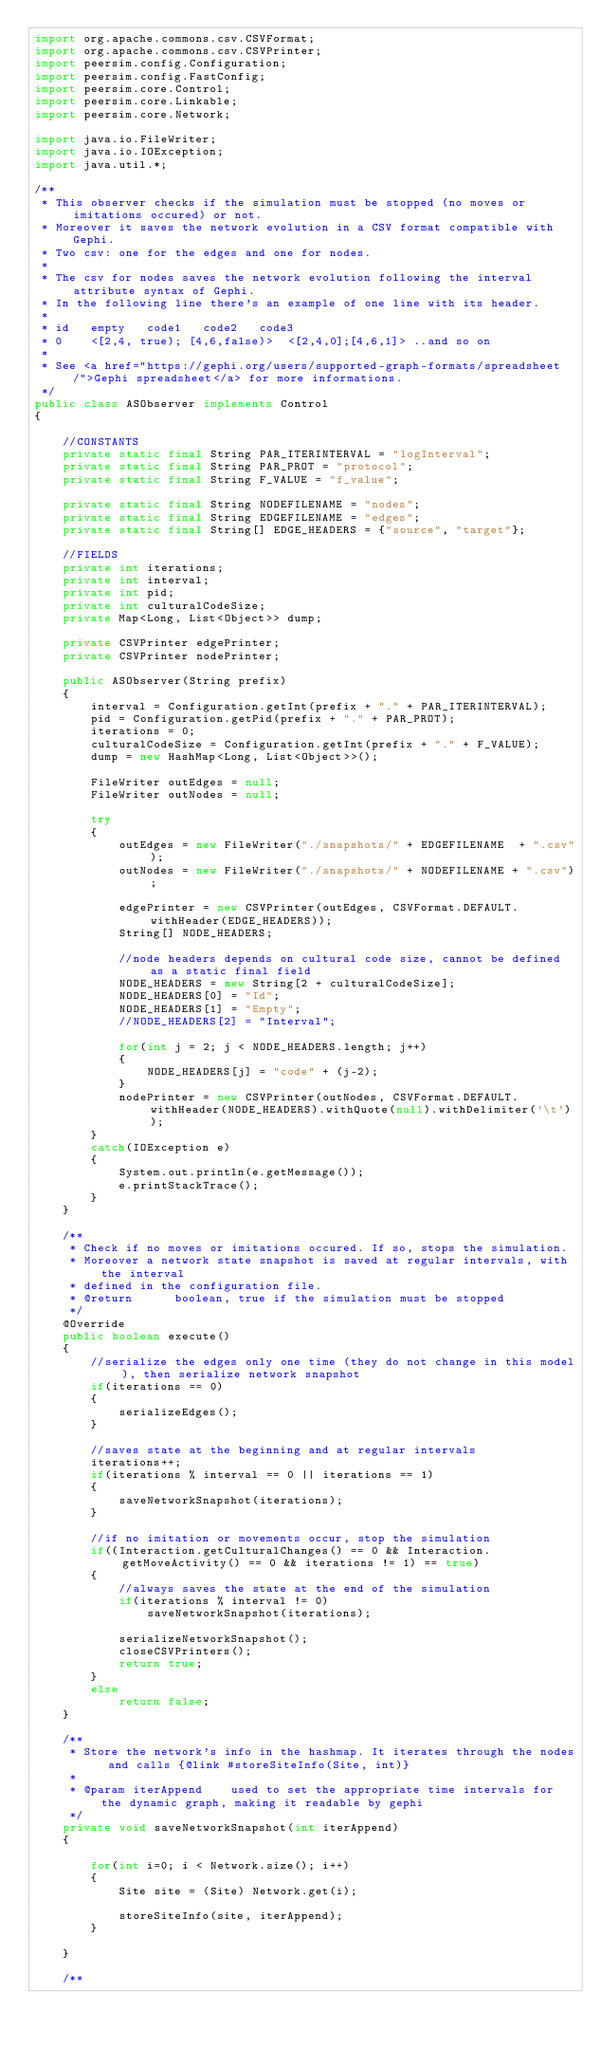<code> <loc_0><loc_0><loc_500><loc_500><_Java_>import org.apache.commons.csv.CSVFormat;
import org.apache.commons.csv.CSVPrinter;
import peersim.config.Configuration;
import peersim.config.FastConfig;
import peersim.core.Control;
import peersim.core.Linkable;
import peersim.core.Network;

import java.io.FileWriter;
import java.io.IOException;
import java.util.*;

/**
 * This observer checks if the simulation must be stopped (no moves or imitations occured) or not.
 * Moreover it saves the network evolution in a CSV format compatible with Gephi.
 * Two csv: one for the edges and one for nodes.
 *
 * The csv for nodes saves the network evolution following the interval attribute syntax of Gephi.
 * In the following line there's an example of one line with its header.
 *
 * id   empty   code1   code2   code3
 * 0    <[2,4, true); [4,6,false)>  <[2,4,0];[4,6,1]> ..and so on
 *
 * See <a href="https://gephi.org/users/supported-graph-formats/spreadsheet/">Gephi spreadsheet</a> for more informations.
 */
public class ASObserver implements Control
{

    //CONSTANTS
    private static final String PAR_ITERINTERVAL = "logInterval";
    private static final String PAR_PROT = "protocol";
    private static final String F_VALUE = "f_value";

    private static final String NODEFILENAME = "nodes";
    private static final String EDGEFILENAME = "edges";
    private static final String[] EDGE_HEADERS = {"source", "target"};

    //FIELDS
    private int iterations;
    private int interval;
    private int pid;
    private int culturalCodeSize;
    private Map<Long, List<Object>> dump;

    private CSVPrinter edgePrinter;
    private CSVPrinter nodePrinter;

    public ASObserver(String prefix)
    {
        interval = Configuration.getInt(prefix + "." + PAR_ITERINTERVAL);
        pid = Configuration.getPid(prefix + "." + PAR_PROT);
        iterations = 0;
        culturalCodeSize = Configuration.getInt(prefix + "." + F_VALUE);
        dump = new HashMap<Long, List<Object>>();

        FileWriter outEdges = null;
        FileWriter outNodes = null;

        try
        {
            outEdges = new FileWriter("./snapshots/" + EDGEFILENAME  + ".csv");
            outNodes = new FileWriter("./snapshots/" + NODEFILENAME + ".csv");

            edgePrinter = new CSVPrinter(outEdges, CSVFormat.DEFAULT.withHeader(EDGE_HEADERS));
            String[] NODE_HEADERS;

            //node headers depends on cultural code size, cannot be defined as a static final field
            NODE_HEADERS = new String[2 + culturalCodeSize];
            NODE_HEADERS[0] = "Id";
            NODE_HEADERS[1] = "Empty";
            //NODE_HEADERS[2] = "Interval";

            for(int j = 2; j < NODE_HEADERS.length; j++)
            {
                NODE_HEADERS[j] = "code" + (j-2);
            }
            nodePrinter = new CSVPrinter(outNodes, CSVFormat.DEFAULT.withHeader(NODE_HEADERS).withQuote(null).withDelimiter('\t'));
        }
        catch(IOException e)
        {
            System.out.println(e.getMessage());
            e.printStackTrace();
        }
    }

    /**
     * Check if no moves or imitations occured. If so, stops the simulation.
     * Moreover a network state snapshot is saved at regular intervals, with the interval
     * defined in the configuration file.
     * @return      boolean, true if the simulation must be stopped
     */
    @Override
    public boolean execute()
    {
        //serialize the edges only one time (they do not change in this model), then serialize network snapshot
        if(iterations == 0)
        {
            serializeEdges();
        }

        //saves state at the beginning and at regular intervals
        iterations++;
        if(iterations % interval == 0 || iterations == 1)
        {
            saveNetworkSnapshot(iterations);
        }

        //if no imitation or movements occur, stop the simulation
        if((Interaction.getCulturalChanges() == 0 && Interaction.getMoveActivity() == 0 && iterations != 1) == true)
        {
            //always saves the state at the end of the simulation
            if(iterations % interval != 0)
                saveNetworkSnapshot(iterations);

            serializeNetworkSnapshot();
            closeCSVPrinters();
            return true;
        }
        else
            return false;
    }

    /**
     * Store the network's info in the hashmap. It iterates through the nodes and calls {@link #storeSiteInfo(Site, int)}
     *
     * @param iterAppend    used to set the appropriate time intervals for the dynamic graph, making it readable by gephi
     */
    private void saveNetworkSnapshot(int iterAppend)
    {

        for(int i=0; i < Network.size(); i++)
        {
            Site site = (Site) Network.get(i);

            storeSiteInfo(site, iterAppend);
        }

    }

    /**</code> 